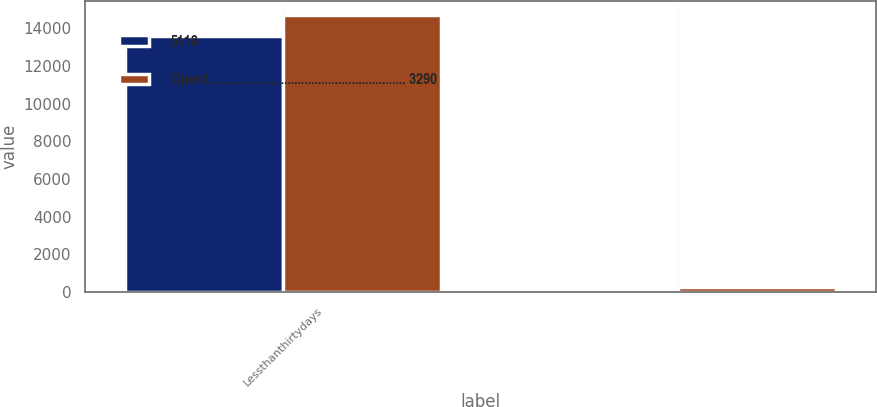<chart> <loc_0><loc_0><loc_500><loc_500><stacked_bar_chart><ecel><fcel>Lessthanthirtydays<fcel>Unnamed: 2<nl><fcel>5118<fcel>13605<fcel>6<nl><fcel>Open1.......................................................... 3290<fcel>14711<fcel>279<nl></chart> 